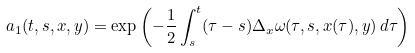<formula> <loc_0><loc_0><loc_500><loc_500>a _ { 1 } ( t , s , x , y ) = \exp \left ( - \frac { 1 } { 2 } \int _ { s } ^ { t } ( \tau - s ) \Delta _ { x } \omega ( \tau , s , x ( \tau ) , y ) \, d \tau \right )</formula> 